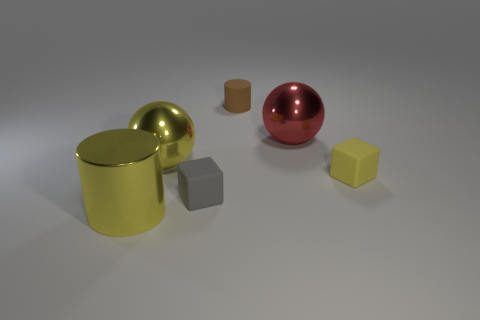Add 1 big yellow cylinders. How many objects exist? 7 Subtract 1 cubes. How many cubes are left? 1 Subtract all blue cubes. Subtract all brown cylinders. How many cubes are left? 2 Subtract all purple balls. How many green blocks are left? 0 Subtract all small rubber cubes. Subtract all tiny blue metallic spheres. How many objects are left? 4 Add 6 yellow metal objects. How many yellow metal objects are left? 8 Add 4 rubber balls. How many rubber balls exist? 4 Subtract 1 gray blocks. How many objects are left? 5 Subtract all balls. How many objects are left? 4 